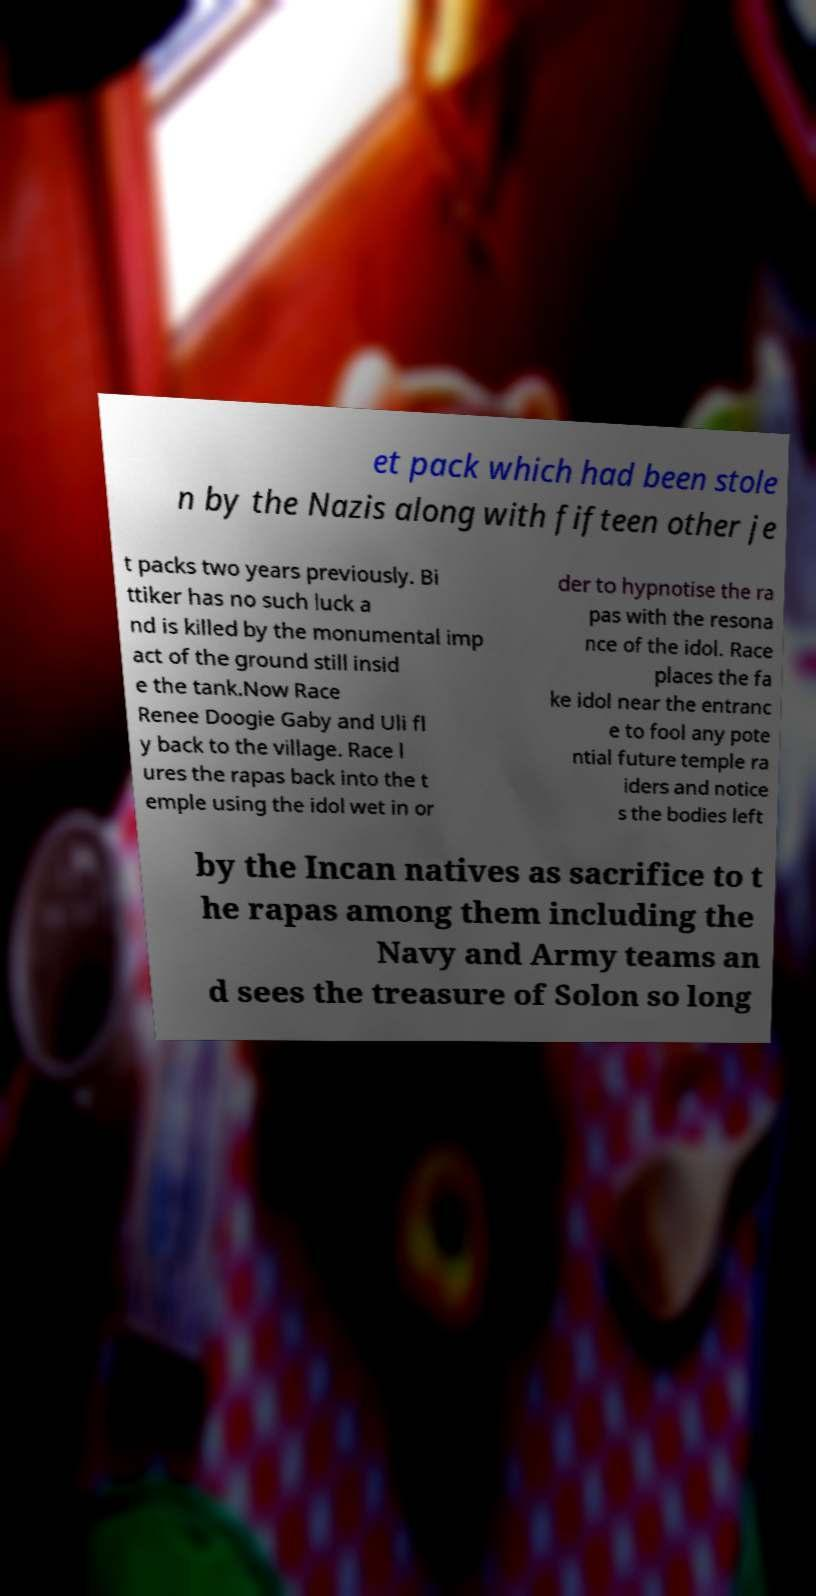I need the written content from this picture converted into text. Can you do that? et pack which had been stole n by the Nazis along with fifteen other je t packs two years previously. Bi ttiker has no such luck a nd is killed by the monumental imp act of the ground still insid e the tank.Now Race Renee Doogie Gaby and Uli fl y back to the village. Race l ures the rapas back into the t emple using the idol wet in or der to hypnotise the ra pas with the resona nce of the idol. Race places the fa ke idol near the entranc e to fool any pote ntial future temple ra iders and notice s the bodies left by the Incan natives as sacrifice to t he rapas among them including the Navy and Army teams an d sees the treasure of Solon so long 